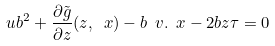Convert formula to latex. <formula><loc_0><loc_0><loc_500><loc_500>u b ^ { 2 } + \frac { \partial \tilde { g } } { \partial z } ( z , \ x ) - b \ v . \ x - 2 b z \tau = 0</formula> 